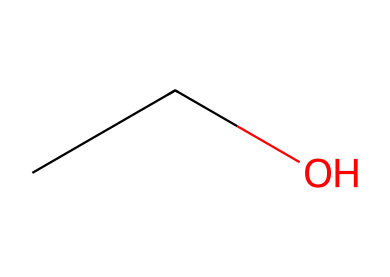What is the molecular formula of this chemical? The SMILES representation "CCO" indicates that there are two carbon (C) atoms and six hydrogen (H) atoms, as well as one oxygen (O) atom. Thus, the molecular formula is determined to be C2H6O.
Answer: C2H6O How many carbon atoms are present? In the SMILES representation "CCO," each "C" represents a carbon atom. There are two "C" characters, indicating that there are two carbon atoms in the molecule.
Answer: 2 What type of functional group is present in this chemical? The presence of the "OH" part of the structure indicates that it has a hydroxyl group, which is characteristic of alcohols, making ethanol an alcohol.
Answer: hydroxyl Is this chemical flammable? Ethanol is commonly known to be a flammable liquid, and as it is represented by the SMILES "CCO," it confirms the properties of alcohols which are typically flammable.
Answer: yes What is the boiling point of ethanol? Ethanol typically has a boiling point around 78.37 degrees Celsius under standard atmospheric conditions. This is a known property of ethanol.
Answer: 78.37 How many hydrogen atoms are bonded to the carbon atoms? Each carbon in the "CCO" is bonded to three hydrogen atoms (the first carbon) and two hydrogen atoms (the second carbon) due to the structure of ethanol, leading to a total of six hydrogen atoms bonded to carbon.
Answer: 6 What type of chemical is represented in a hand sanitizer? Hand sanitizers typically contain ethanol as their primary active ingredient, making them an alcohol-based chemical product. The structure shown in the SMILES is representative of such an alcohol.
Answer: alcohol 